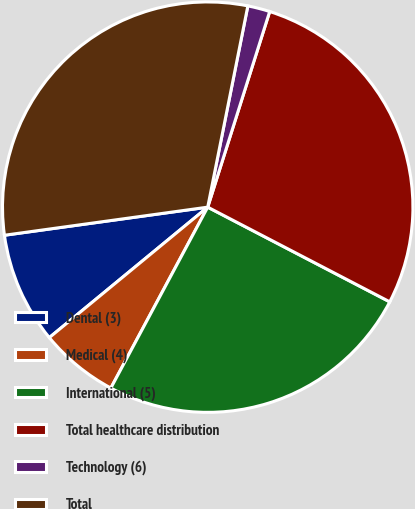Convert chart to OTSL. <chart><loc_0><loc_0><loc_500><loc_500><pie_chart><fcel>Dental (3)<fcel>Medical (4)<fcel>International (5)<fcel>Total healthcare distribution<fcel>Technology (6)<fcel>Total<nl><fcel>8.78%<fcel>6.21%<fcel>25.19%<fcel>27.75%<fcel>1.75%<fcel>30.32%<nl></chart> 